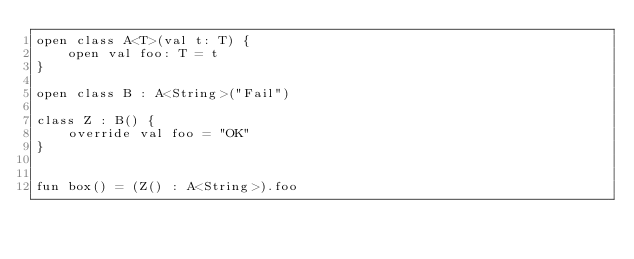Convert code to text. <code><loc_0><loc_0><loc_500><loc_500><_Kotlin_>open class A<T>(val t: T) {
    open val foo: T = t
}

open class B : A<String>("Fail")

class Z : B() {
    override val foo = "OK"
}


fun box() = (Z() : A<String>).foo
</code> 